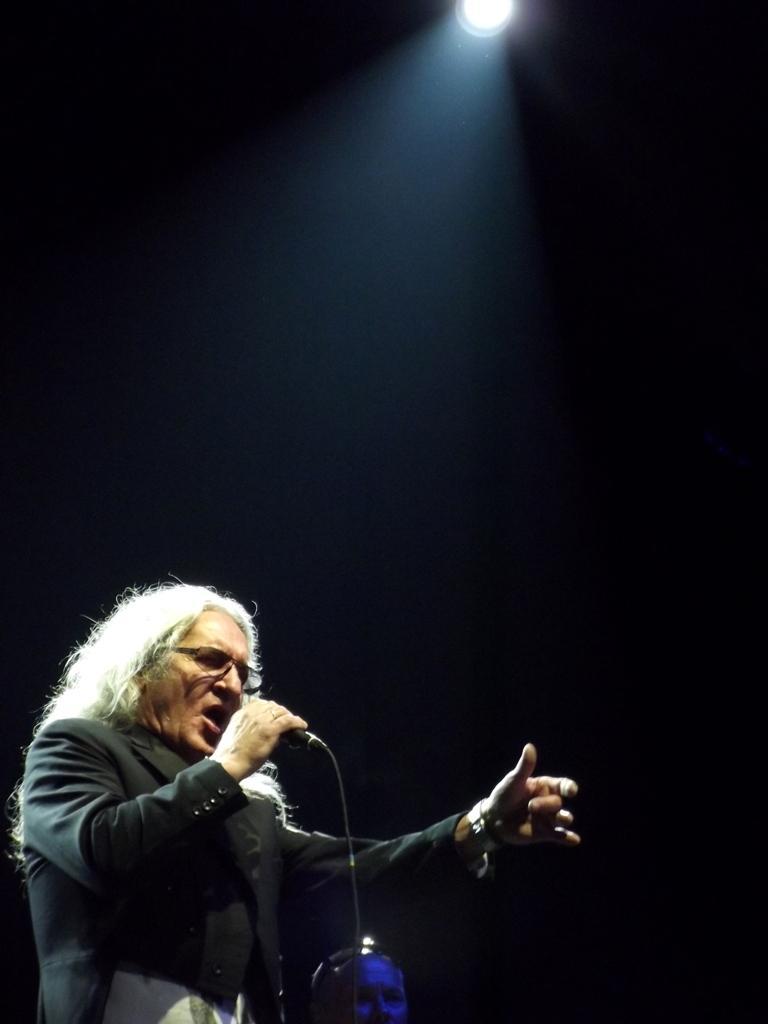Describe this image in one or two sentences. In this image I can see a person wearing black color dress and holding a microphone, background I can see a light. 